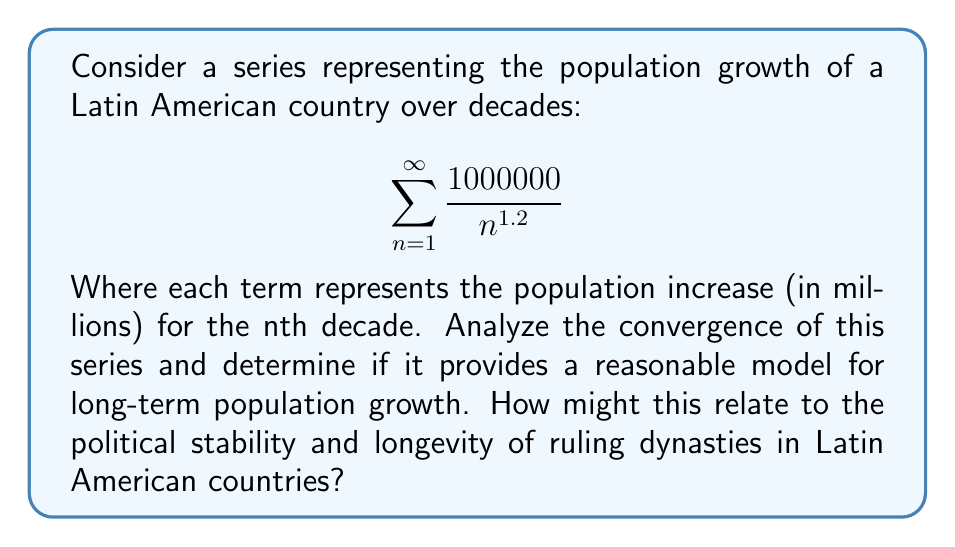What is the answer to this math problem? To analyze the convergence of this series, we'll use the p-series test:

1) The general form of a p-series is $\sum_{n=1}^{\infty} \frac{1}{n^p}$

2) Our series can be rewritten as $1000000 \sum_{n=1}^{\infty} \frac{1}{n^{1.2}}$

3) For a p-series:
   - If $p > 1$, the series converges
   - If $p \leq 1$, the series diverges

4) In our case, $p = 1.2$, which is greater than 1

5) Therefore, this series converges

6) To find the sum, we can use the Riemann zeta function:
   $\zeta(1.2) \approx 5.591448$

7) So, the sum of our series is approximately:
   $1000000 \cdot 5.591448 \approx 5,591,448$

This model suggests that the population would increase by about 5.59 million people over an infinite number of decades, which is not realistic for long-term population growth. In reality, population growth is more complex and can be affected by various factors such as economic conditions, political stability, and social changes.

Relating this to political dynasties in Latin America:

1) The convergence of the series implies a slowing population growth over time, which could lead to more stable political environments.

2) However, the unrealistic long-term prediction highlights the limitations of simple mathematical models in predicting complex social and political phenomena.

3) Political dynasties might find it easier to maintain power in periods of predictable, slower population growth, but would need to adapt to the actual, more complex population dynamics to remain relevant.
Answer: The series converges because it is a p-series with $p = 1.2 > 1$. The sum of the series is approximately 5,591,448. However, this model is not realistic for long-term population growth, highlighting the need for more complex models when studying the interplay between population dynamics and political stability in Latin American countries. 